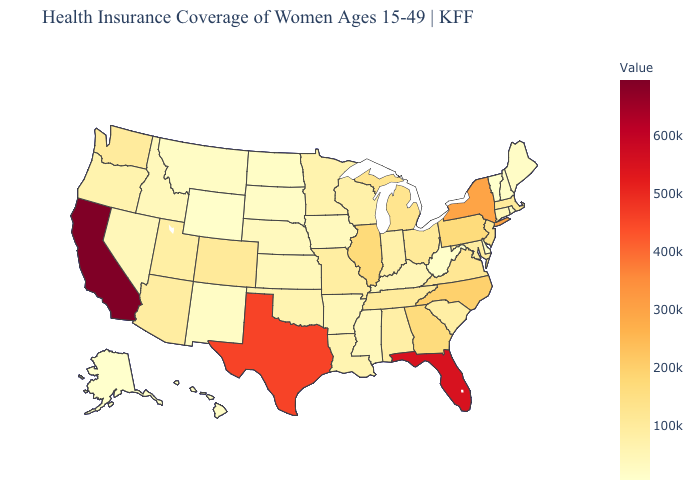Among the states that border Missouri , does Nebraska have the highest value?
Concise answer only. No. Does the map have missing data?
Concise answer only. No. Which states have the lowest value in the South?
Give a very brief answer. West Virginia. Does Indiana have a higher value than New York?
Give a very brief answer. No. Among the states that border New Hampshire , does Massachusetts have the lowest value?
Keep it brief. No. Among the states that border Maine , which have the highest value?
Concise answer only. New Hampshire. 